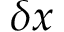Convert formula to latex. <formula><loc_0><loc_0><loc_500><loc_500>\delta x</formula> 